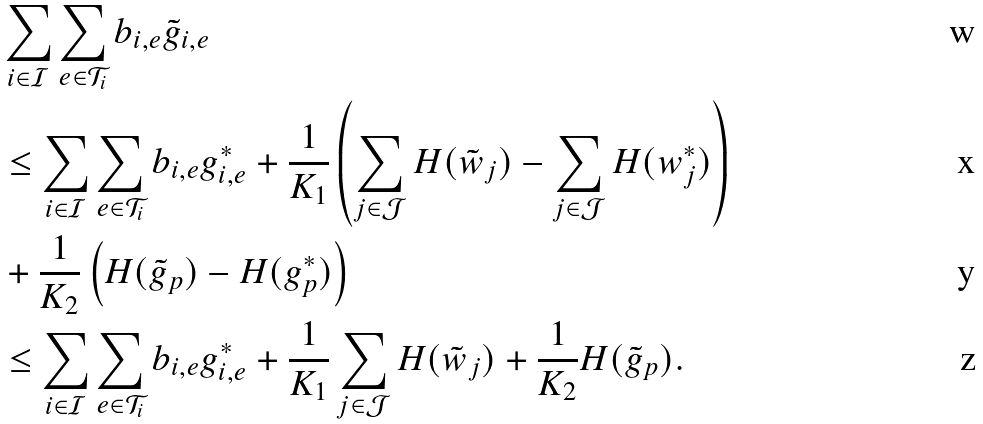<formula> <loc_0><loc_0><loc_500><loc_500>& \sum _ { i \in \mathcal { I } } \sum _ { e \in \mathcal { T } _ { i } } b _ { i , e } \tilde { g } _ { i , e } \\ & \leq \sum _ { i \in \mathcal { I } } \sum _ { e \in \mathcal { T } _ { i } } b _ { i , e } g _ { i , e } ^ { * } + \frac { 1 } { K _ { 1 } } \left ( \sum _ { j \in \mathcal { J } } H ( \tilde { w } _ { j } ) - \sum _ { j \in \mathcal { J } } H ( w _ { j } ^ { * } ) \right ) \\ & + \frac { 1 } { K _ { 2 } } \left ( H ( \tilde { g } _ { p } ) - H ( g _ { p } ^ { * } ) \right ) \\ & \leq \sum _ { i \in \mathcal { I } } \sum _ { e \in \mathcal { T } _ { i } } b _ { i , e } g _ { i , e } ^ { * } + \frac { 1 } { K _ { 1 } } \sum _ { j \in \mathcal { J } } H ( \tilde { w } _ { j } ) + \frac { 1 } { K _ { 2 } } H ( \tilde { g } _ { p } ) .</formula> 